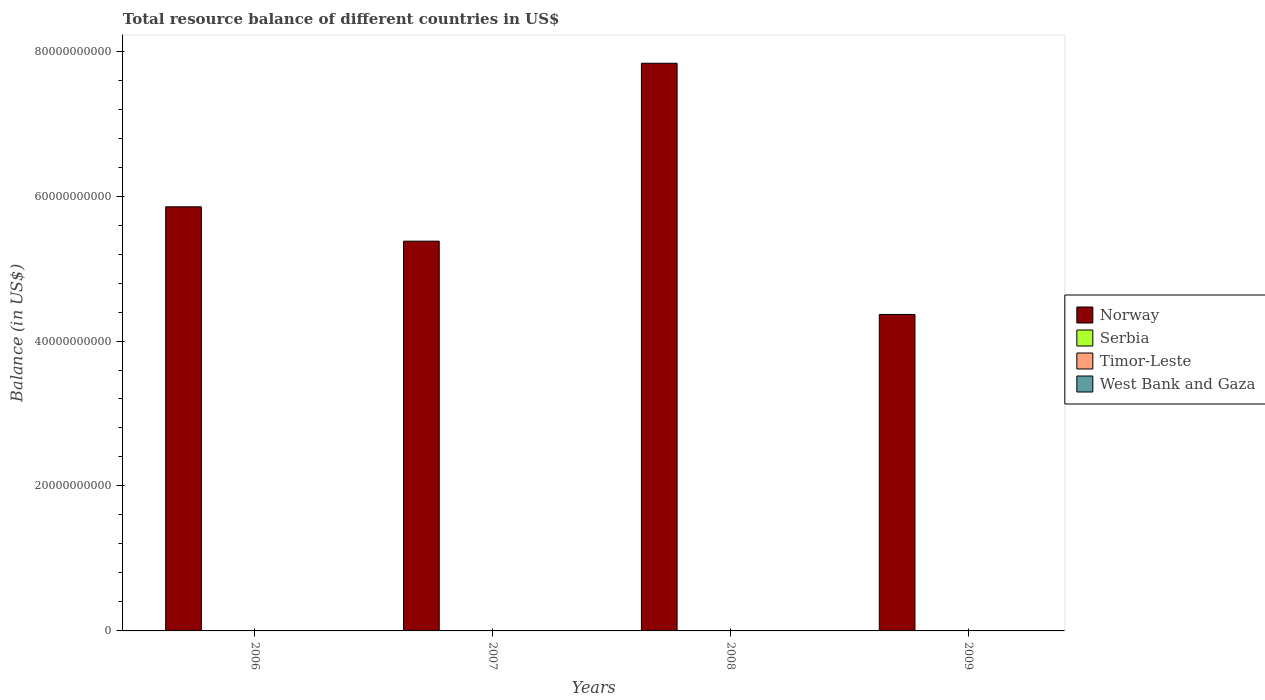Are the number of bars per tick equal to the number of legend labels?
Offer a terse response. No. Are the number of bars on each tick of the X-axis equal?
Ensure brevity in your answer.  Yes. How many bars are there on the 1st tick from the left?
Provide a short and direct response. 1. How many bars are there on the 4th tick from the right?
Give a very brief answer. 1. What is the label of the 4th group of bars from the left?
Your answer should be compact. 2009. Across all years, what is the maximum total resource balance in Norway?
Provide a succinct answer. 7.83e+1. Across all years, what is the minimum total resource balance in West Bank and Gaza?
Give a very brief answer. 0. What is the total total resource balance in West Bank and Gaza in the graph?
Ensure brevity in your answer.  0. What is the difference between the total resource balance in Norway in 2007 and that in 2008?
Keep it short and to the point. -2.45e+1. What is the average total resource balance in Timor-Leste per year?
Your answer should be compact. 0. In how many years, is the total resource balance in Timor-Leste greater than 28000000000 US$?
Offer a very short reply. 0. What is the difference between the highest and the second highest total resource balance in Norway?
Provide a short and direct response. 1.98e+1. What is the difference between the highest and the lowest total resource balance in Norway?
Give a very brief answer. 3.47e+1. In how many years, is the total resource balance in Norway greater than the average total resource balance in Norway taken over all years?
Keep it short and to the point. 1. Is the sum of the total resource balance in Norway in 2006 and 2007 greater than the maximum total resource balance in West Bank and Gaza across all years?
Provide a succinct answer. Yes. Is it the case that in every year, the sum of the total resource balance in Serbia and total resource balance in Timor-Leste is greater than the sum of total resource balance in West Bank and Gaza and total resource balance in Norway?
Provide a succinct answer. No. Is it the case that in every year, the sum of the total resource balance in Timor-Leste and total resource balance in West Bank and Gaza is greater than the total resource balance in Norway?
Your answer should be compact. No. How many bars are there?
Your answer should be very brief. 4. How many years are there in the graph?
Ensure brevity in your answer.  4. What is the difference between two consecutive major ticks on the Y-axis?
Make the answer very short. 2.00e+1. Does the graph contain grids?
Make the answer very short. No. Where does the legend appear in the graph?
Make the answer very short. Center right. How are the legend labels stacked?
Provide a succinct answer. Vertical. What is the title of the graph?
Keep it short and to the point. Total resource balance of different countries in US$. What is the label or title of the Y-axis?
Offer a terse response. Balance (in US$). What is the Balance (in US$) of Norway in 2006?
Keep it short and to the point. 5.85e+1. What is the Balance (in US$) in West Bank and Gaza in 2006?
Your answer should be very brief. 0. What is the Balance (in US$) of Norway in 2007?
Provide a short and direct response. 5.38e+1. What is the Balance (in US$) in Serbia in 2007?
Your response must be concise. 0. What is the Balance (in US$) of Timor-Leste in 2007?
Provide a succinct answer. 0. What is the Balance (in US$) in Norway in 2008?
Keep it short and to the point. 7.83e+1. What is the Balance (in US$) of Norway in 2009?
Provide a short and direct response. 4.37e+1. What is the Balance (in US$) in Serbia in 2009?
Your response must be concise. 0. What is the Balance (in US$) in Timor-Leste in 2009?
Your answer should be compact. 0. Across all years, what is the maximum Balance (in US$) in Norway?
Give a very brief answer. 7.83e+1. Across all years, what is the minimum Balance (in US$) in Norway?
Your response must be concise. 4.37e+1. What is the total Balance (in US$) in Norway in the graph?
Make the answer very short. 2.34e+11. What is the total Balance (in US$) of Serbia in the graph?
Offer a very short reply. 0. What is the total Balance (in US$) of West Bank and Gaza in the graph?
Your answer should be compact. 0. What is the difference between the Balance (in US$) of Norway in 2006 and that in 2007?
Provide a succinct answer. 4.74e+09. What is the difference between the Balance (in US$) in Norway in 2006 and that in 2008?
Keep it short and to the point. -1.98e+1. What is the difference between the Balance (in US$) in Norway in 2006 and that in 2009?
Give a very brief answer. 1.49e+1. What is the difference between the Balance (in US$) in Norway in 2007 and that in 2008?
Give a very brief answer. -2.45e+1. What is the difference between the Balance (in US$) of Norway in 2007 and that in 2009?
Your answer should be compact. 1.01e+1. What is the difference between the Balance (in US$) in Norway in 2008 and that in 2009?
Provide a succinct answer. 3.47e+1. What is the average Balance (in US$) in Norway per year?
Provide a succinct answer. 5.86e+1. What is the average Balance (in US$) in Timor-Leste per year?
Offer a very short reply. 0. What is the average Balance (in US$) in West Bank and Gaza per year?
Offer a terse response. 0. What is the ratio of the Balance (in US$) of Norway in 2006 to that in 2007?
Give a very brief answer. 1.09. What is the ratio of the Balance (in US$) of Norway in 2006 to that in 2008?
Provide a succinct answer. 0.75. What is the ratio of the Balance (in US$) in Norway in 2006 to that in 2009?
Offer a very short reply. 1.34. What is the ratio of the Balance (in US$) in Norway in 2007 to that in 2008?
Provide a short and direct response. 0.69. What is the ratio of the Balance (in US$) of Norway in 2007 to that in 2009?
Provide a succinct answer. 1.23. What is the ratio of the Balance (in US$) of Norway in 2008 to that in 2009?
Your answer should be very brief. 1.79. What is the difference between the highest and the second highest Balance (in US$) of Norway?
Make the answer very short. 1.98e+1. What is the difference between the highest and the lowest Balance (in US$) in Norway?
Offer a terse response. 3.47e+1. 